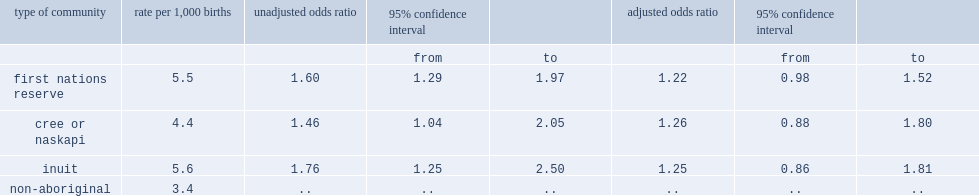Was the stillbirth rate for aboriginal people living on first nations reserves higher or was that for non-aboriginal people? First nations reserve. Was the stillbirth rate for aboriginal people living in cree and naskapi communities higher or was that for non-aboriginal people? Cree or naskapi. Was the stillbirth rate for aboriginal people living in inuit communities higher or was that for non-aboriginal people? Inuit. 